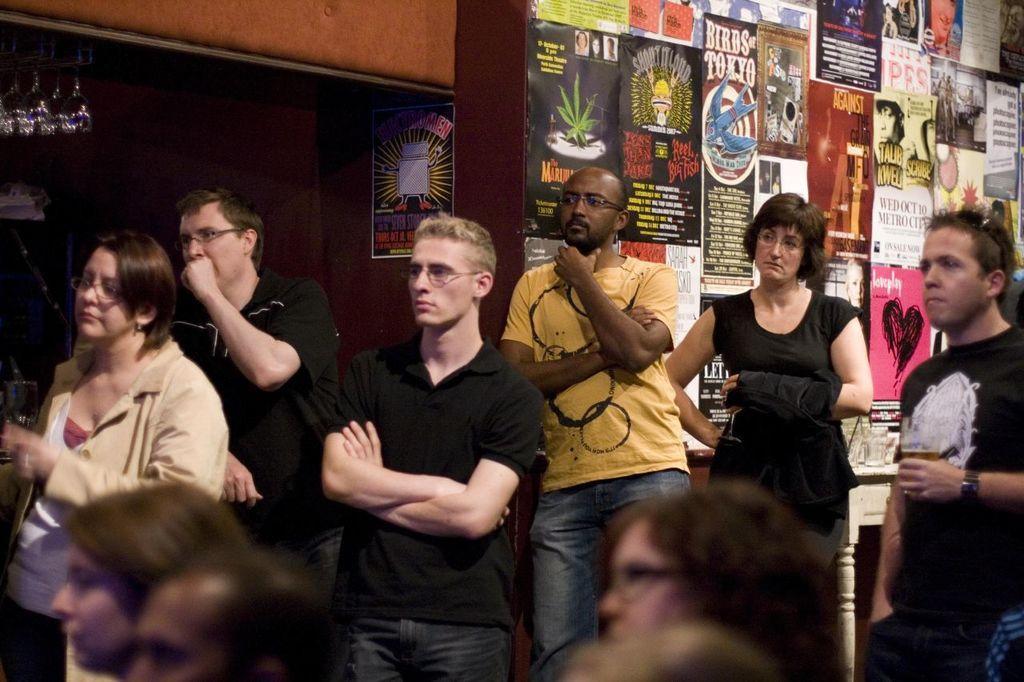In one or two sentences, can you explain what this image depicts? In this image I can see number of people are standing and behind them I can see number of posters on the wall. On the top left side of this image I can see few glasses. 